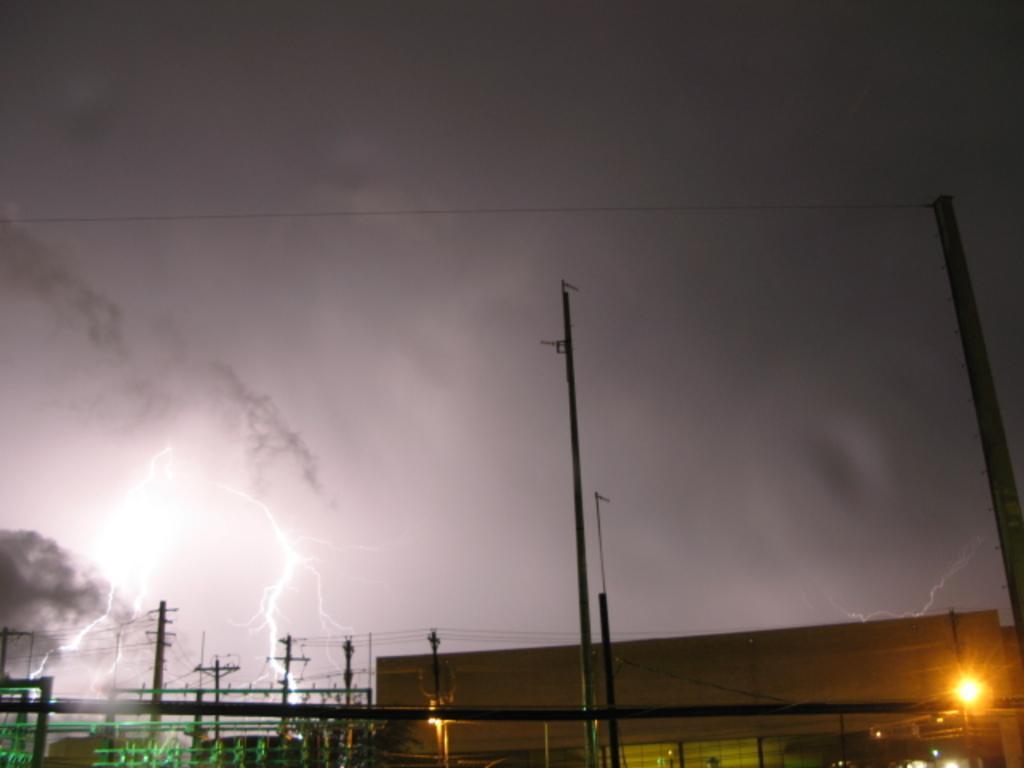In one or two sentences, can you explain what this image depicts? In this image we can see sky with clouds, lightning, electric poles, electric cables, buildings and electric lights. 